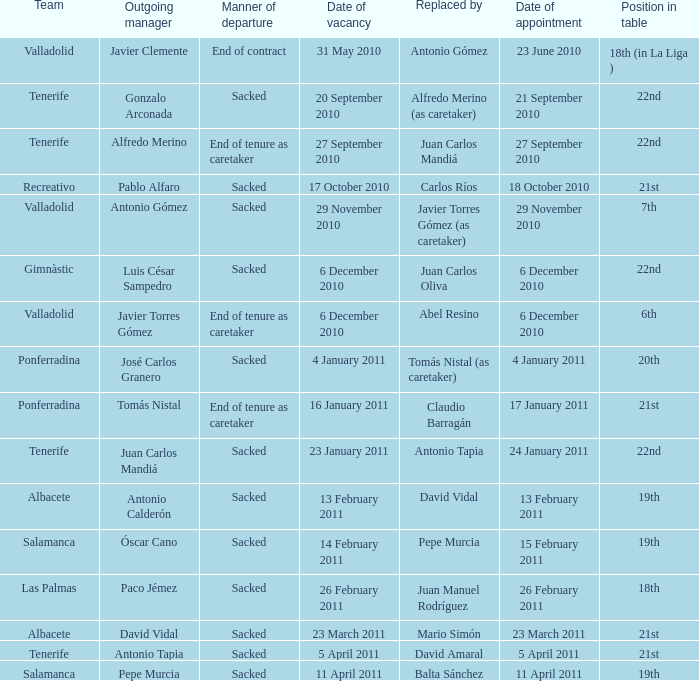What is the job for departing manager alfredo merino? 22nd. 